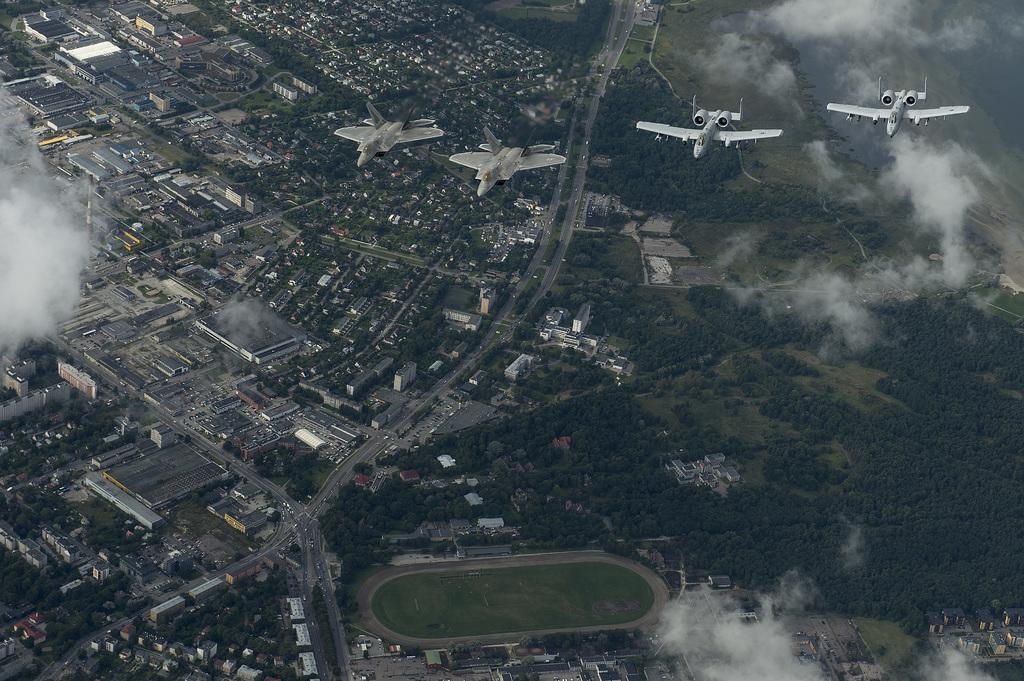What is in the sky in the image? There are aeroplanes in the sky in the image. What can be seen in the background of the image? There are buildings, trees, and vehicles on the road in the background. Can you describe the smoke visible in the image? Yes, there is smoke visible in the image. What effect does the story have on the change in the image? There is no story present in the image, and therefore no effect on any change can be determined. 